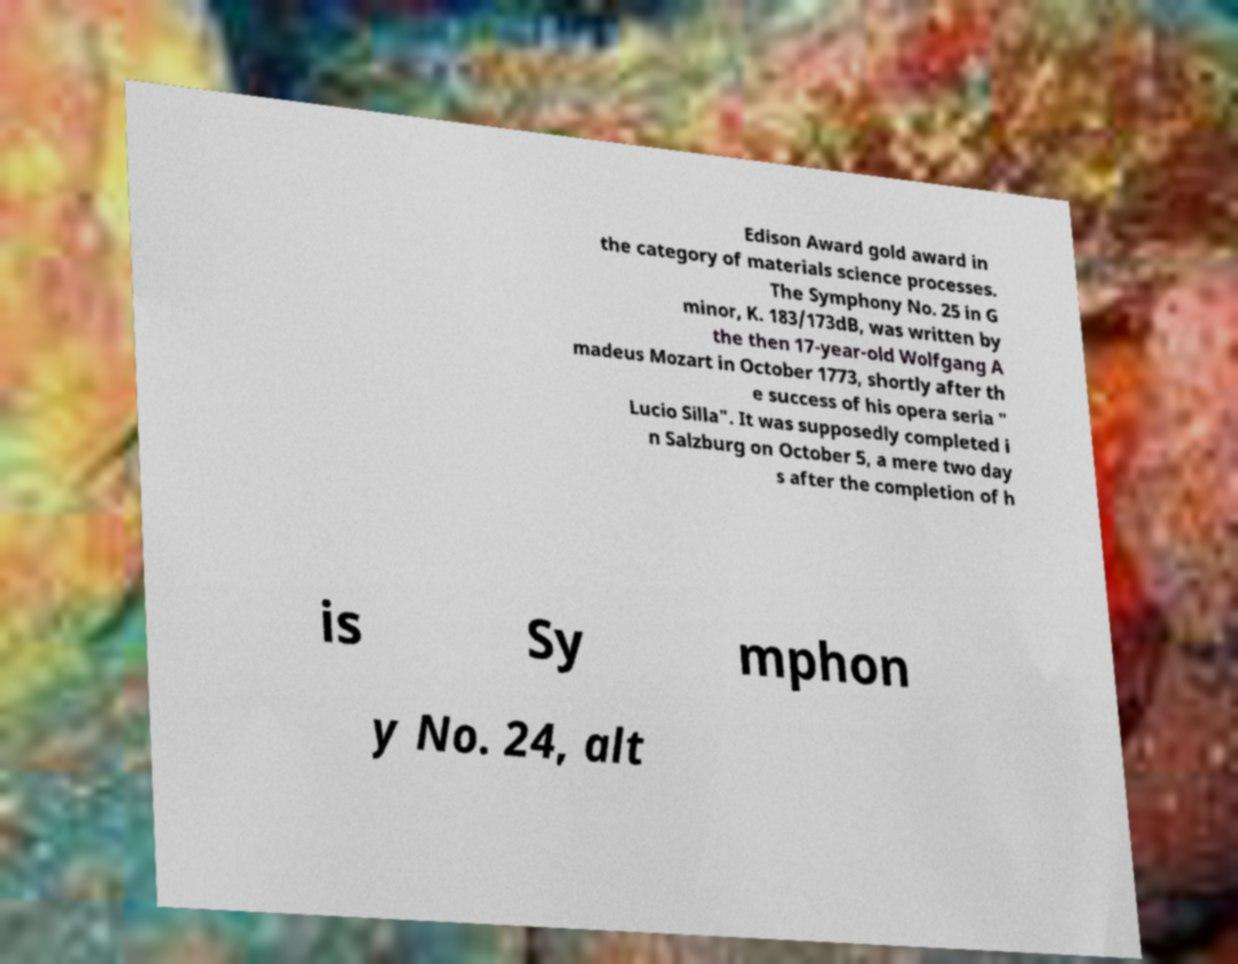What messages or text are displayed in this image? I need them in a readable, typed format. Edison Award gold award in the category of materials science processes. The Symphony No. 25 in G minor, K. 183/173dB, was written by the then 17-year-old Wolfgang A madeus Mozart in October 1773, shortly after th e success of his opera seria " Lucio Silla". It was supposedly completed i n Salzburg on October 5, a mere two day s after the completion of h is Sy mphon y No. 24, alt 